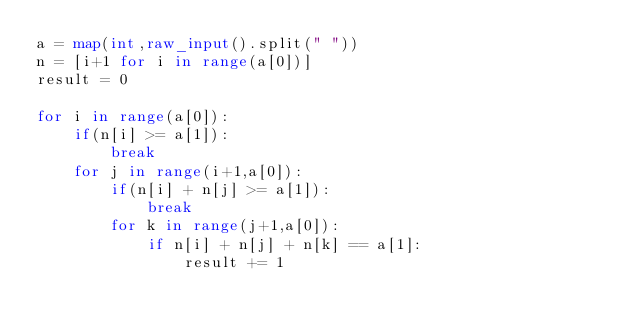<code> <loc_0><loc_0><loc_500><loc_500><_Python_>a = map(int,raw_input().split(" "))
n = [i+1 for i in range(a[0])]
result = 0

for i in range(a[0]):
    if(n[i] >= a[1]):
        break
    for j in range(i+1,a[0]):
        if(n[i] + n[j] >= a[1]):
            break
        for k in range(j+1,a[0]):
            if n[i] + n[j] + n[k] == a[1]:
                result += 1</code> 